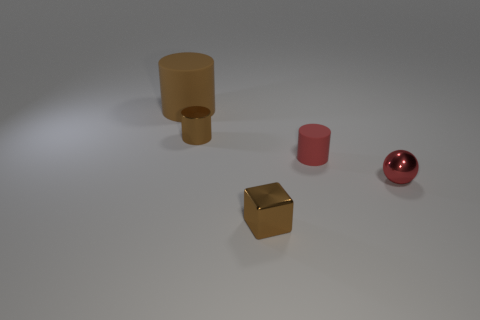Add 2 small things. How many objects exist? 7 Subtract all balls. How many objects are left? 4 Add 3 large matte cylinders. How many large matte cylinders exist? 4 Subtract 1 brown cubes. How many objects are left? 4 Subtract all tiny brown metallic cubes. Subtract all tiny rubber things. How many objects are left? 3 Add 1 large brown rubber things. How many large brown rubber things are left? 2 